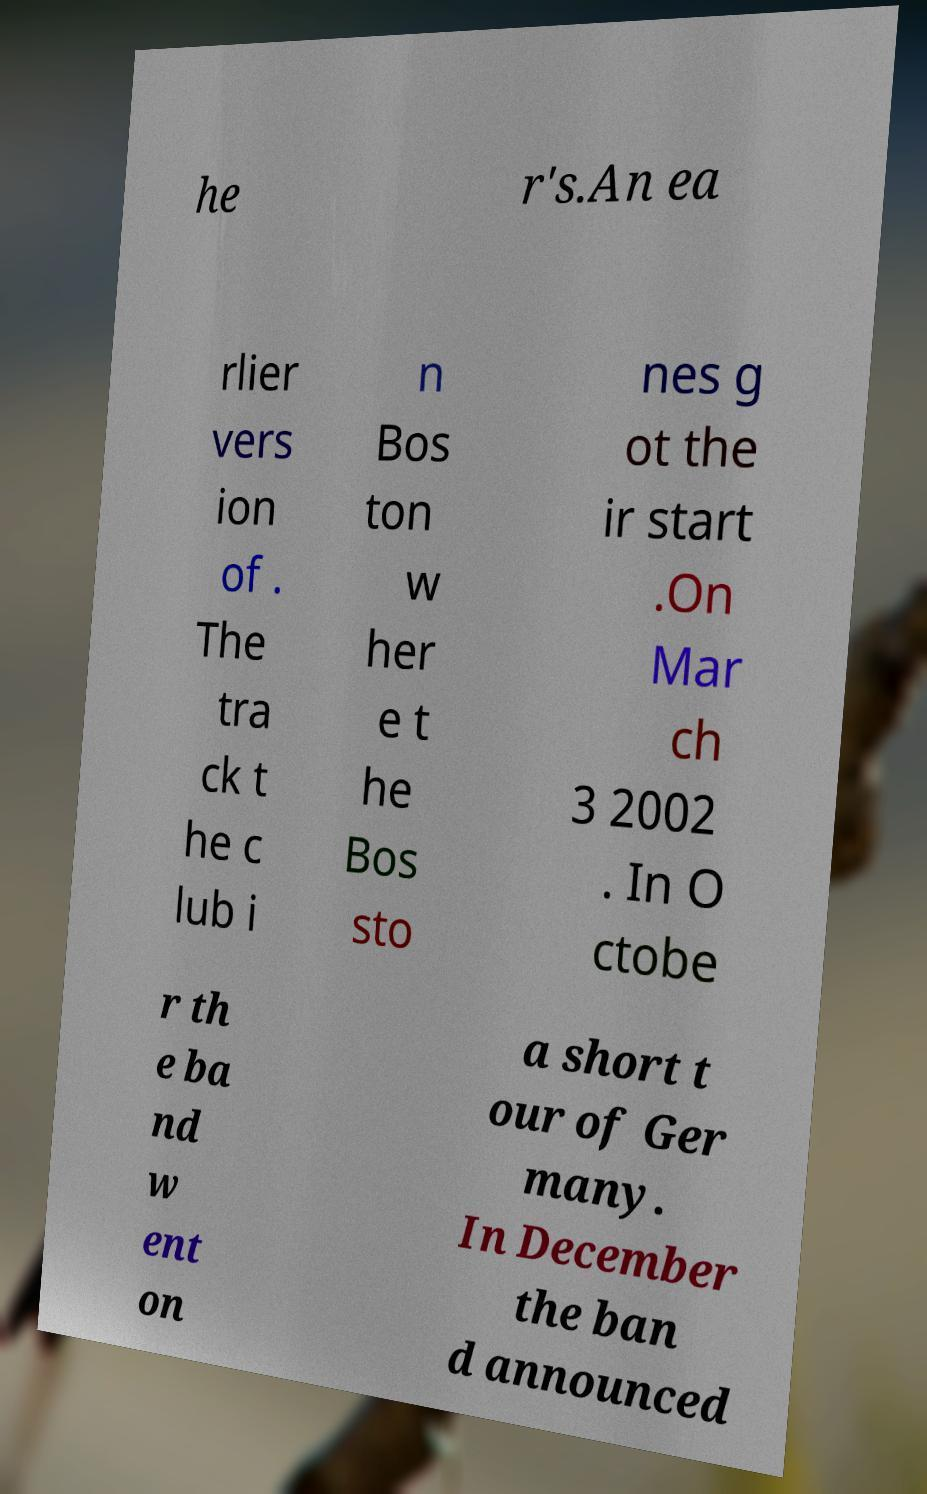Could you extract and type out the text from this image? he r's.An ea rlier vers ion of . The tra ck t he c lub i n Bos ton w her e t he Bos sto nes g ot the ir start .On Mar ch 3 2002 . In O ctobe r th e ba nd w ent on a short t our of Ger many. In December the ban d announced 